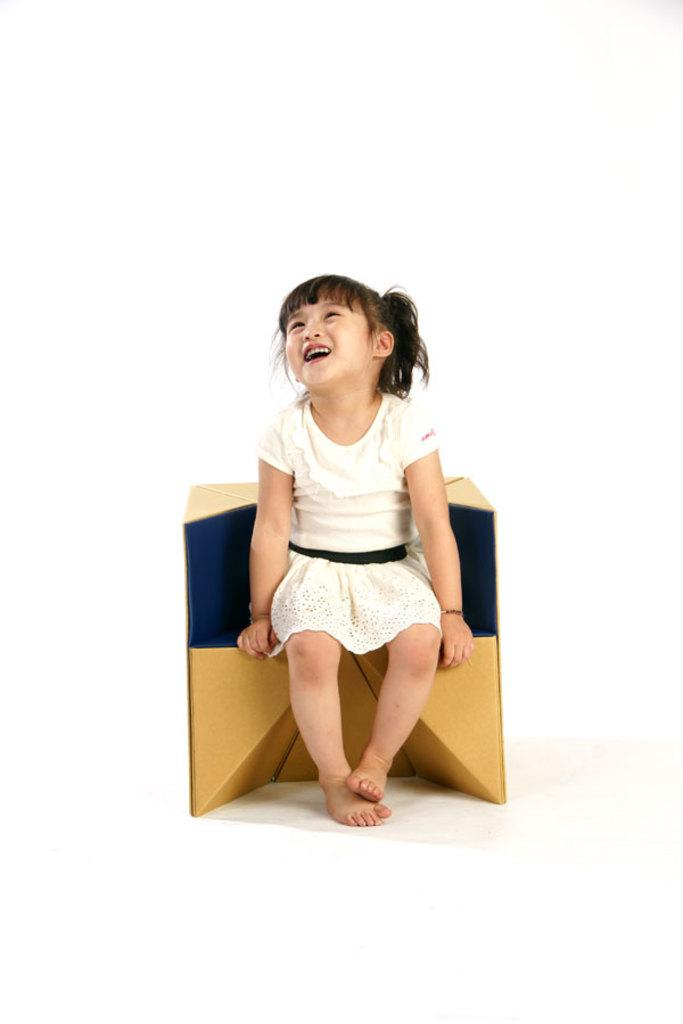Who is the main subject in the image? There is a girl in the image. What is the girl wearing? The girl is wearing a white dress. What is the girl doing in the image? The girl is sitting and smiling. What is behind the girl in the image? There is a chair or a carton box behind the girl. What is the color of the background in the image? The background of the image is white in color. How many visitors are present in the image? There is no mention of any visitors in the image; it only features a girl. What type of railway is visible in the image? There is no railway present in the image. 